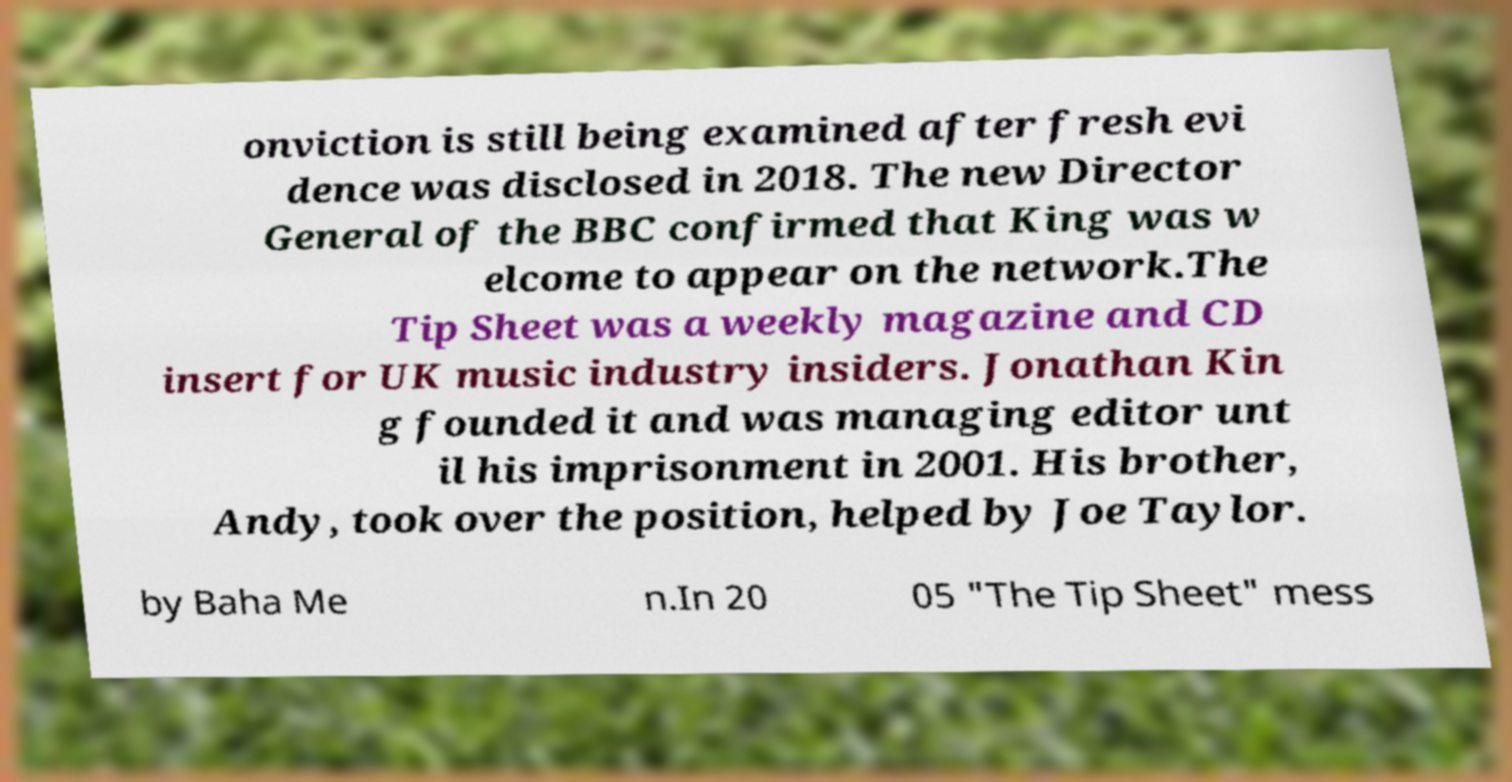Could you extract and type out the text from this image? onviction is still being examined after fresh evi dence was disclosed in 2018. The new Director General of the BBC confirmed that King was w elcome to appear on the network.The Tip Sheet was a weekly magazine and CD insert for UK music industry insiders. Jonathan Kin g founded it and was managing editor unt il his imprisonment in 2001. His brother, Andy, took over the position, helped by Joe Taylor. by Baha Me n.In 20 05 "The Tip Sheet" mess 